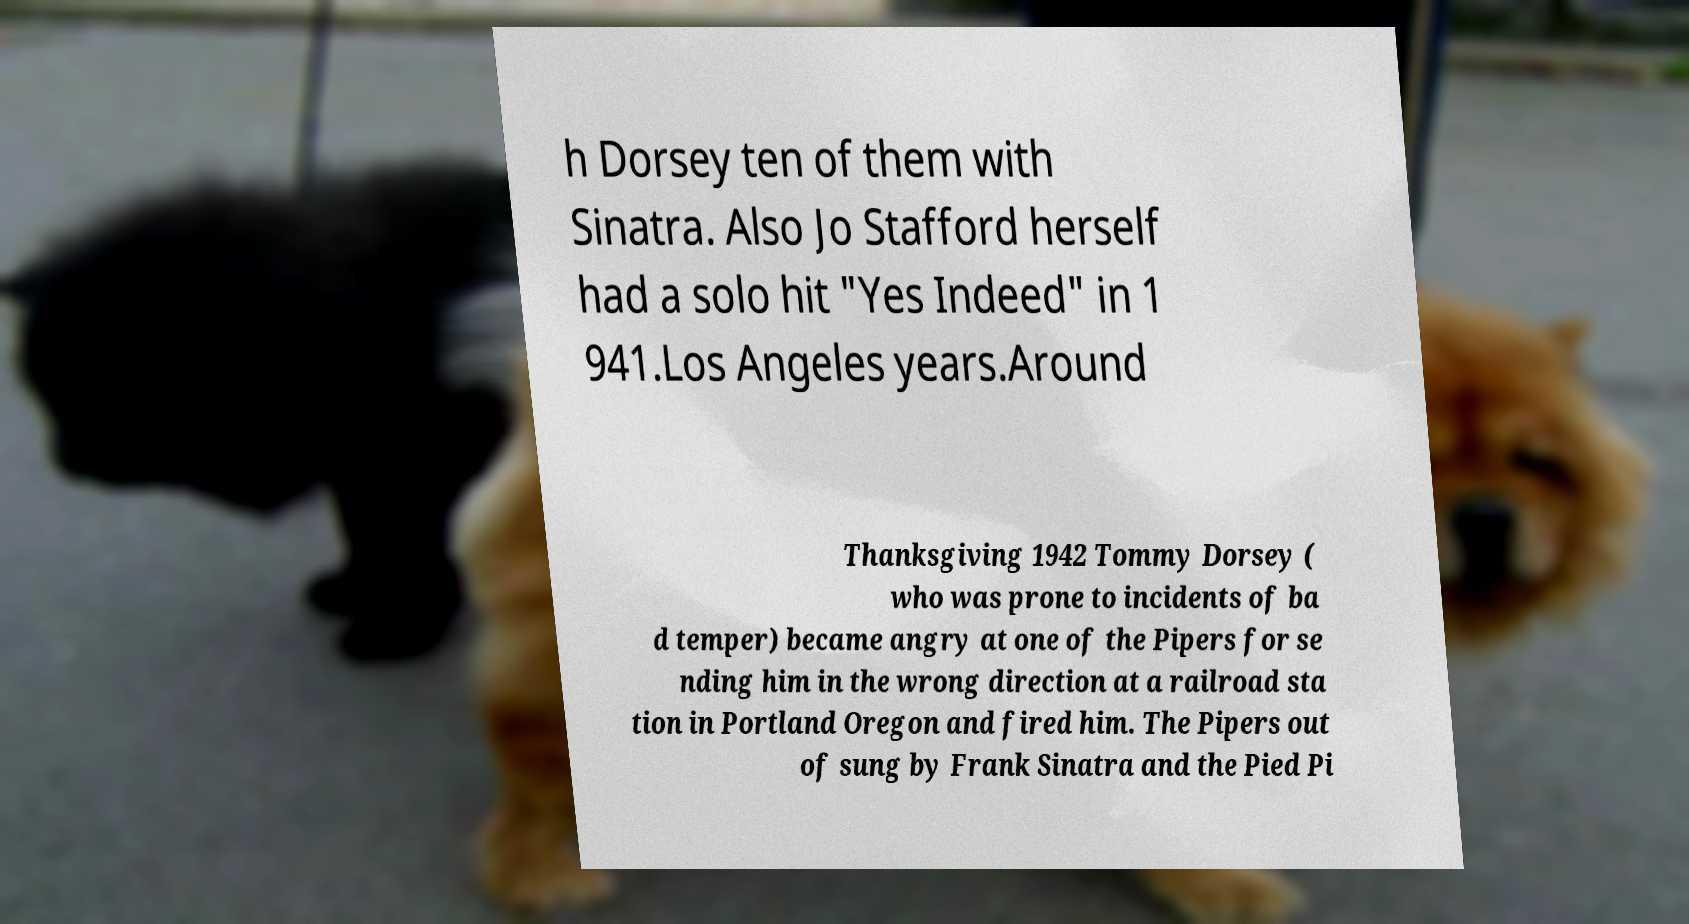Please identify and transcribe the text found in this image. h Dorsey ten of them with Sinatra. Also Jo Stafford herself had a solo hit "Yes Indeed" in 1 941.Los Angeles years.Around Thanksgiving 1942 Tommy Dorsey ( who was prone to incidents of ba d temper) became angry at one of the Pipers for se nding him in the wrong direction at a railroad sta tion in Portland Oregon and fired him. The Pipers out of sung by Frank Sinatra and the Pied Pi 